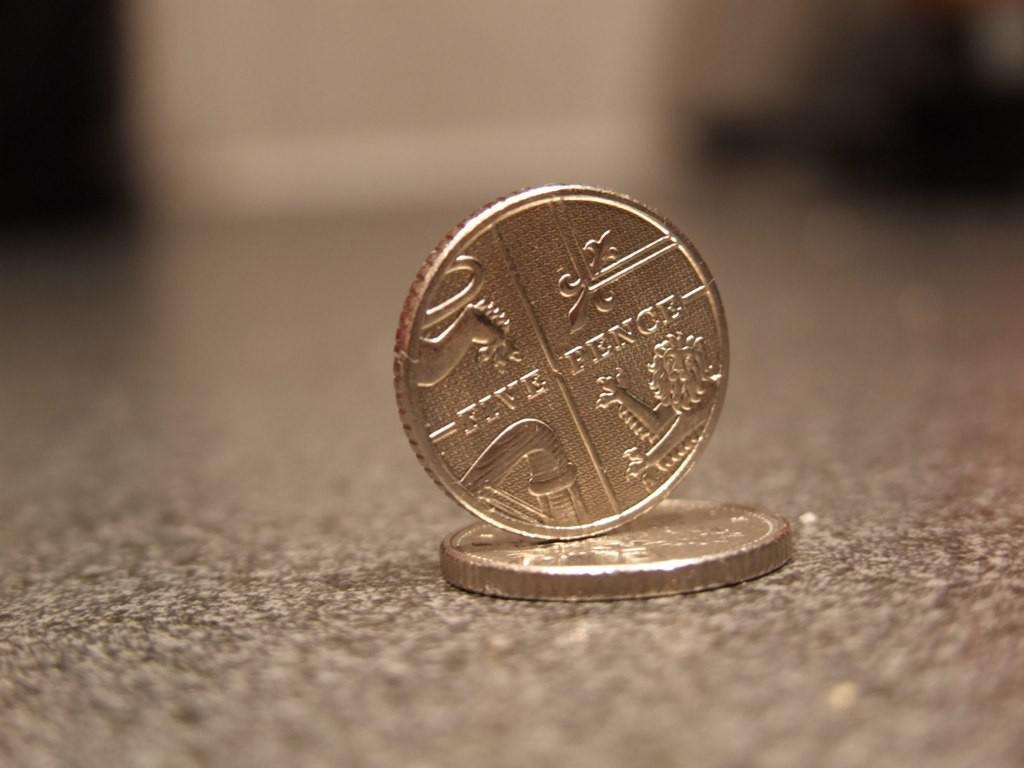Provide a one-sentence caption for the provided image. Five Pence is displayed on the coin balancing on another. 